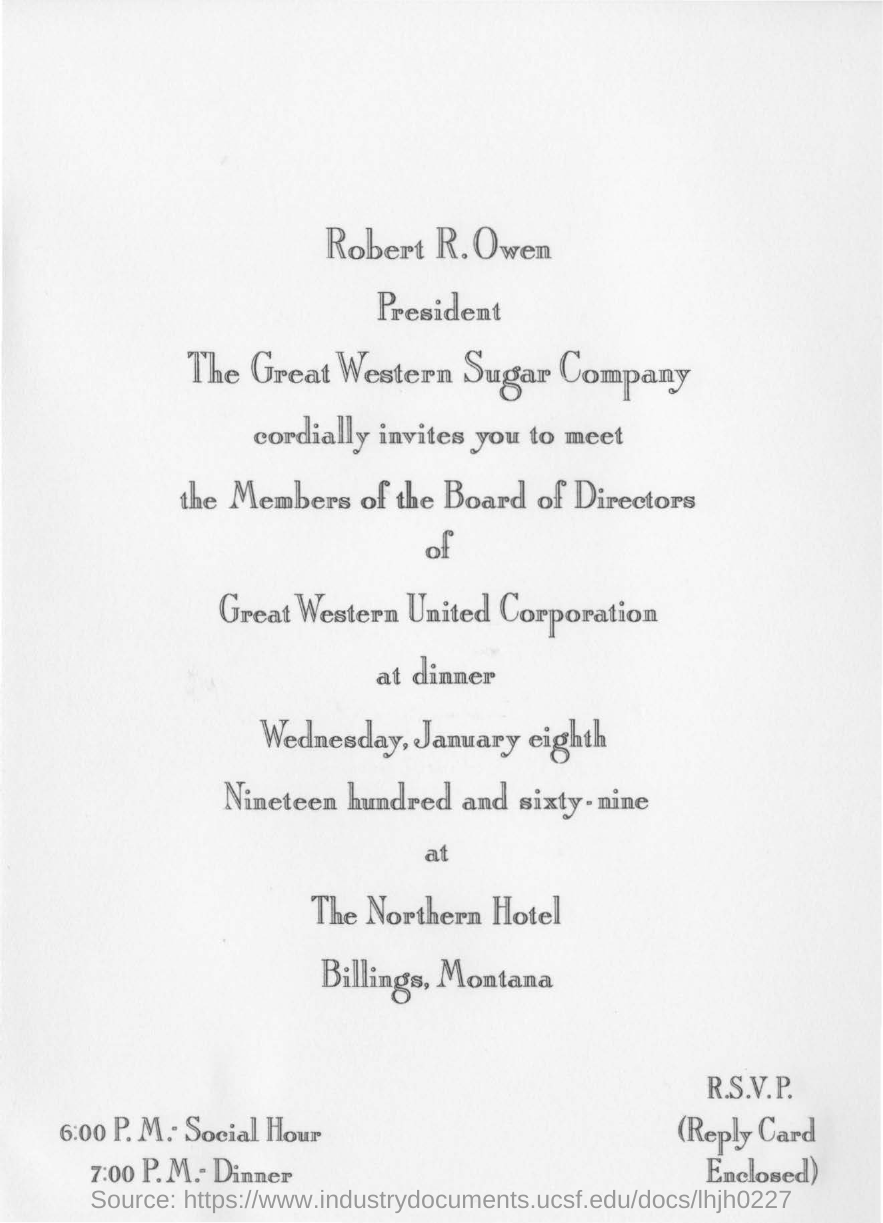Who is the president of The Great Western Sugar Company?
Your response must be concise. Robert R. Owen. Who is the sender of the invitation?
Your response must be concise. Robert R. Owen. Where is the dinner held?
Make the answer very short. The Northern Hotel. On what date is the dinner?
Provide a succinct answer. Wednesday, January eighth Nineteen hundred and sixty-nine. 